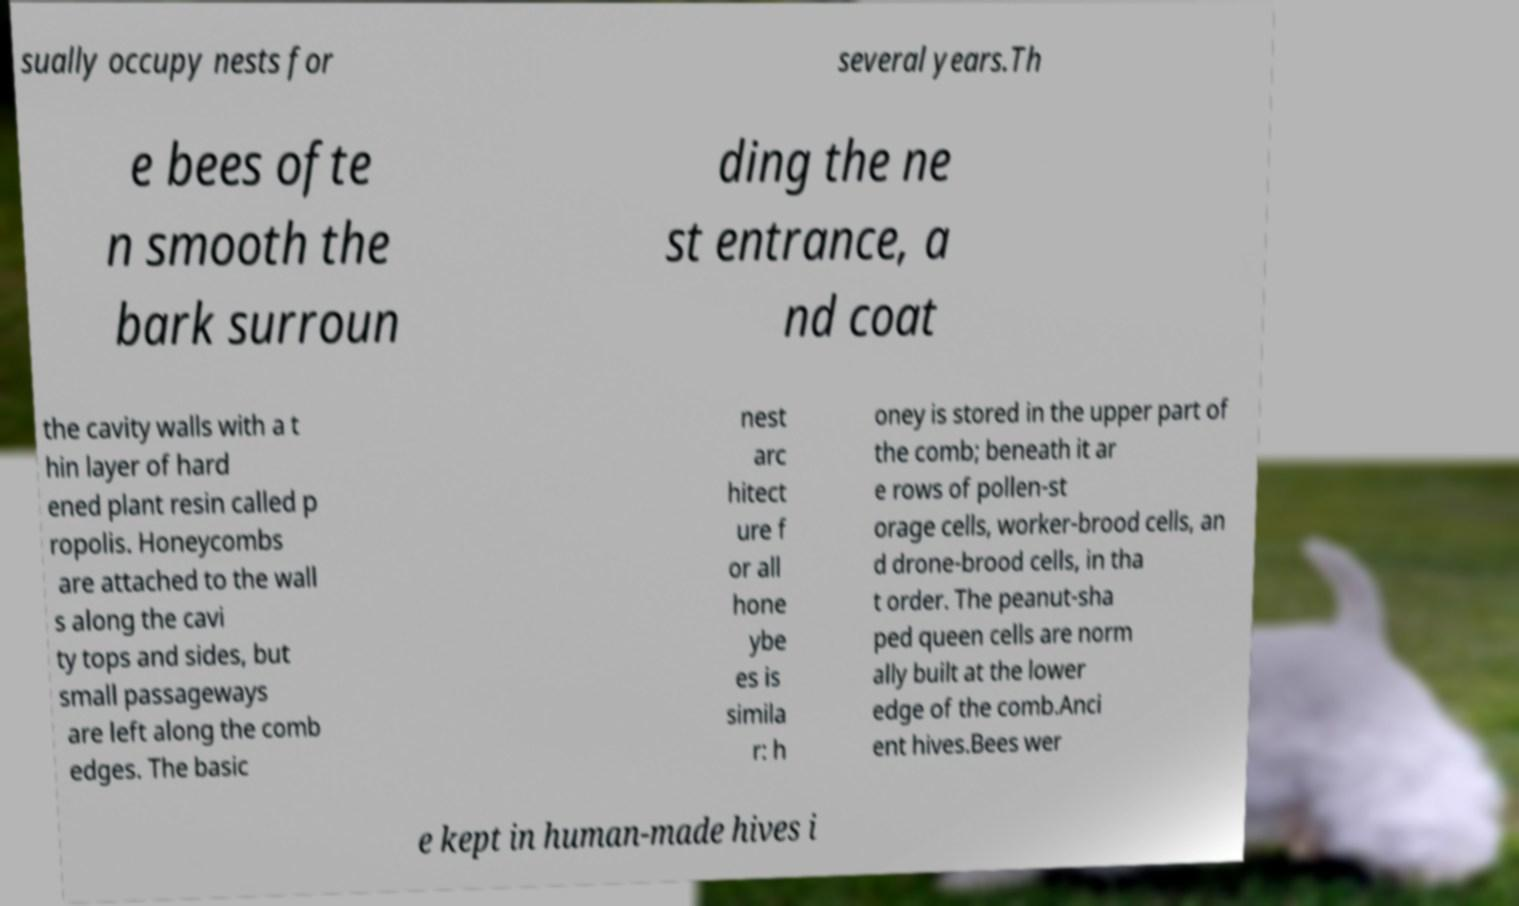I need the written content from this picture converted into text. Can you do that? sually occupy nests for several years.Th e bees ofte n smooth the bark surroun ding the ne st entrance, a nd coat the cavity walls with a t hin layer of hard ened plant resin called p ropolis. Honeycombs are attached to the wall s along the cavi ty tops and sides, but small passageways are left along the comb edges. The basic nest arc hitect ure f or all hone ybe es is simila r: h oney is stored in the upper part of the comb; beneath it ar e rows of pollen-st orage cells, worker-brood cells, an d drone-brood cells, in tha t order. The peanut-sha ped queen cells are norm ally built at the lower edge of the comb.Anci ent hives.Bees wer e kept in human-made hives i 